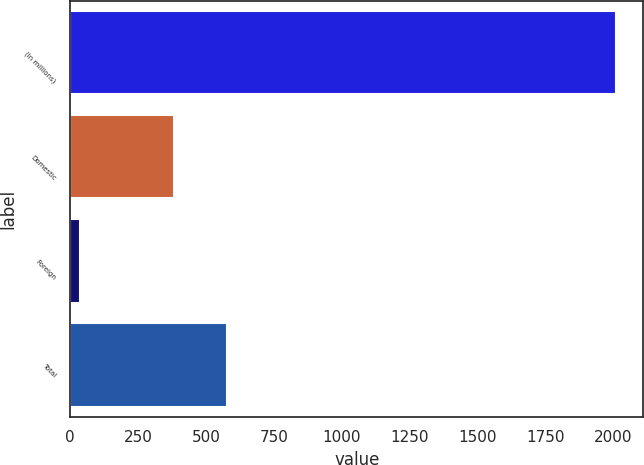Convert chart. <chart><loc_0><loc_0><loc_500><loc_500><bar_chart><fcel>(In millions)<fcel>Domestic<fcel>Foreign<fcel>Total<nl><fcel>2010<fcel>382.2<fcel>36.1<fcel>579.59<nl></chart> 